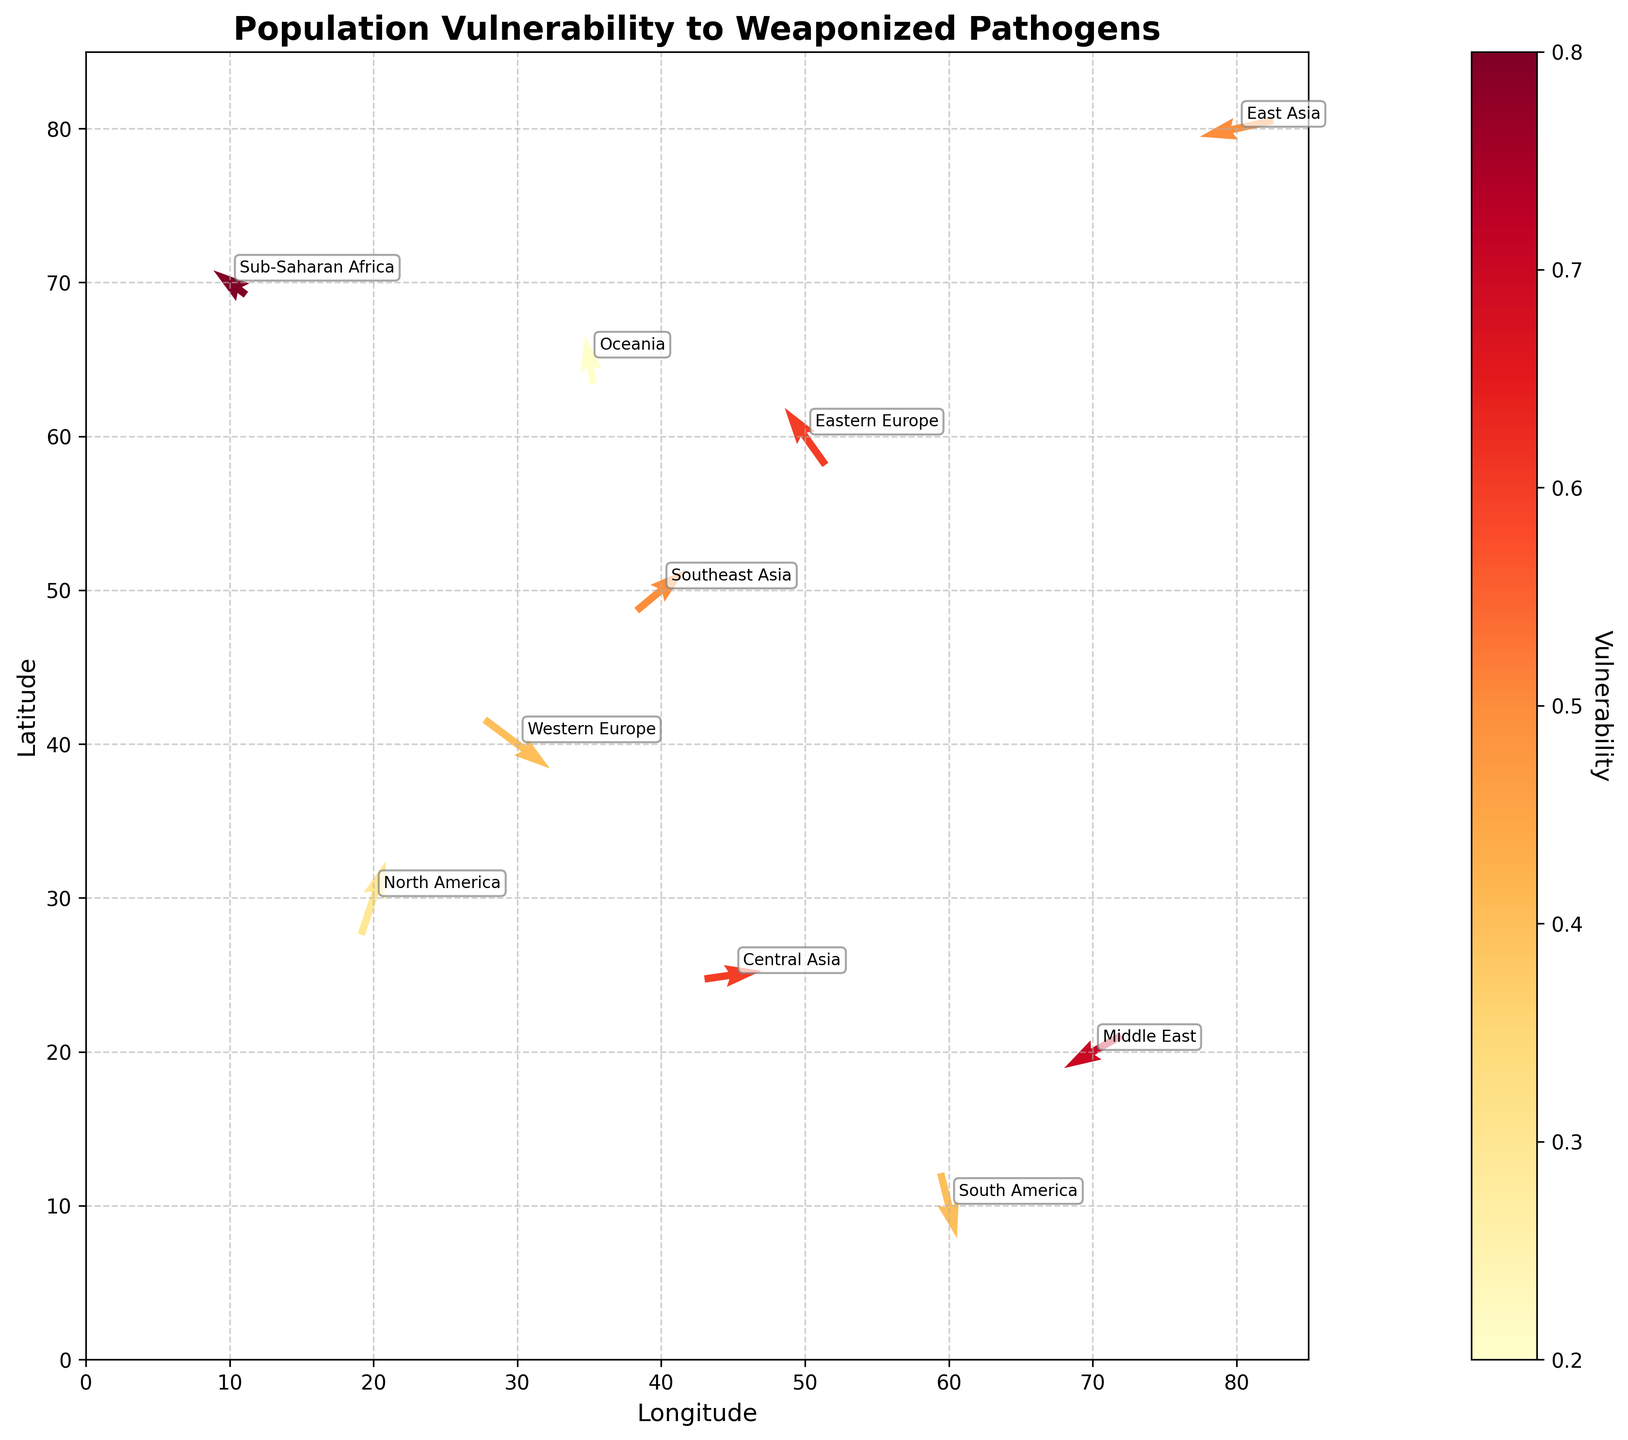What does the title of the figure indicate? The title of the figure is written at the top and reads "Population Vulnerability to Weaponized Pathogens," indicating the plot displays how different geographical regions vary in their vulnerability to bioterrorism threats.
Answer: Population Vulnerability to Weaponized Pathogens How is the vulnerability represented in the figure? Vulnerability is depicted using a color gradient on the arrows in the quiver plot, with the color scheme ranging from light yellow to dark red.
Answer: Color gradient Which region appears to have the highest vulnerability according to the figure? By observing the color of the arrows, Sub-Saharan Africa, with coordinates (10, 70), has the darkest red color, indicating the highest vulnerability.
Answer: Sub-Saharan Africa Compare the direction of the arrows for North America and Middle East. Which direction do they point towards? North America's arrow, located at (20, 30), points predominantly northward and eastward (upwards and rightwards). The Middle East's arrow, located at (70, 20), points primarily westward and southward (leftwards and downward).
Answer: North America: North-east, Middle East: South-west What is the average vulnerability of Eastern Europe, Central Asia, and Oceania? First, identify the vulnerabilities: Eastern Europe (0.6), Central Asia (0.6), Oceania (0.2). Calculate the average as (0.6 + 0.6 + 0.2)/3 = 0.4667.
Answer: 0.47 Which axis represents latitude, and which represents longitude? By referring to the labels of the axes, the y-axis represents latitude, and the x-axis represents longitude.
Answer: Latitude: y-axis, Longitude: x-axis What is the overall trend of the vector direction in Western Europe compared to South America? Western Europe's vector at (30, 40) points towards the Southeast (downwards and rightwards), whereas South America's vector at (60, 10) points predominantly northward and slightly eastward (upwards and rightwards).
Answer: Western Europe: Southeast, South America: North-east Compare the length of the arrows of East Asia and Southeast Asia, and determine which one is longer. East Asia's arrow (80, 80) has components (-0.9, -0.2), and Southeast Asia's arrow (40, 50) has components (0.6, 0.5). The lengths are calculated as sqrt((-0.9)^2 + (-0.2)^2) ≈ 0.92 and sqrt((0.6)^2 + (0.5)^2) ≈ 0.78. Thus, East Asia's is longer.
Answer: East Asia Which region's arrow shows the smallest magnitude of movement? Calculate the magnitude of each vector and find the smallest. For Oceania at (35, 65) with components (-0.1, 0.6), the magnitude is sqrt((-0.1)^2 + (0.6)^2) ≈ 0.61. It is the smallest among all regions.
Answer: Oceania How does vulnerability correlate with the direction of arrows for Sub-Saharan Africa and East Asia? Sub-Saharan Africa (10, 70) has high vulnerability (0.8) and its arrow points northwest (leftwards and slightly upwards). East Asia (80, 80) has medium vulnerability (0.5) and the arrow points southwest (leftwards and downwards). While both move leftwards, vulnerability does not correspond clearly with any dominant directional pattern.
Answer: No clear pattern 